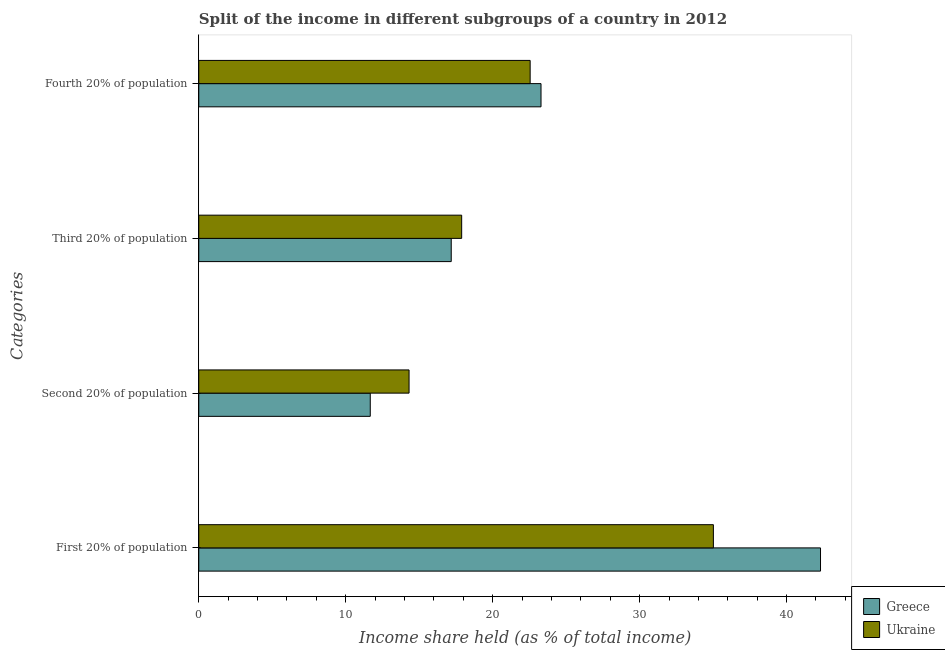How many bars are there on the 3rd tick from the top?
Keep it short and to the point. 2. How many bars are there on the 2nd tick from the bottom?
Ensure brevity in your answer.  2. What is the label of the 1st group of bars from the top?
Your response must be concise. Fourth 20% of population. What is the share of the income held by fourth 20% of the population in Ukraine?
Keep it short and to the point. 22.55. Across all countries, what is the maximum share of the income held by first 20% of the population?
Keep it short and to the point. 42.31. Across all countries, what is the minimum share of the income held by fourth 20% of the population?
Make the answer very short. 22.55. In which country was the share of the income held by second 20% of the population maximum?
Provide a short and direct response. Ukraine. What is the total share of the income held by first 20% of the population in the graph?
Offer a terse response. 77.33. What is the difference between the share of the income held by fourth 20% of the population in Greece and that in Ukraine?
Your answer should be compact. 0.74. What is the difference between the share of the income held by third 20% of the population in Greece and the share of the income held by first 20% of the population in Ukraine?
Provide a short and direct response. -17.84. What is the average share of the income held by fourth 20% of the population per country?
Your answer should be compact. 22.92. What is the difference between the share of the income held by first 20% of the population and share of the income held by second 20% of the population in Greece?
Provide a succinct answer. 30.64. In how many countries, is the share of the income held by third 20% of the population greater than 22 %?
Your response must be concise. 0. What is the ratio of the share of the income held by second 20% of the population in Greece to that in Ukraine?
Ensure brevity in your answer.  0.82. Is the difference between the share of the income held by second 20% of the population in Ukraine and Greece greater than the difference between the share of the income held by fourth 20% of the population in Ukraine and Greece?
Provide a succinct answer. Yes. What is the difference between the highest and the second highest share of the income held by second 20% of the population?
Make the answer very short. 2.64. What is the difference between the highest and the lowest share of the income held by second 20% of the population?
Your answer should be compact. 2.64. In how many countries, is the share of the income held by first 20% of the population greater than the average share of the income held by first 20% of the population taken over all countries?
Make the answer very short. 1. What does the 2nd bar from the top in Second 20% of population represents?
Offer a terse response. Greece. What does the 2nd bar from the bottom in Second 20% of population represents?
Provide a succinct answer. Ukraine. Are all the bars in the graph horizontal?
Provide a short and direct response. Yes. Where does the legend appear in the graph?
Your answer should be compact. Bottom right. How are the legend labels stacked?
Offer a terse response. Vertical. What is the title of the graph?
Provide a short and direct response. Split of the income in different subgroups of a country in 2012. What is the label or title of the X-axis?
Provide a short and direct response. Income share held (as % of total income). What is the label or title of the Y-axis?
Ensure brevity in your answer.  Categories. What is the Income share held (as % of total income) in Greece in First 20% of population?
Your response must be concise. 42.31. What is the Income share held (as % of total income) of Ukraine in First 20% of population?
Your answer should be very brief. 35.02. What is the Income share held (as % of total income) of Greece in Second 20% of population?
Give a very brief answer. 11.67. What is the Income share held (as % of total income) of Ukraine in Second 20% of population?
Offer a terse response. 14.31. What is the Income share held (as % of total income) in Greece in Third 20% of population?
Your response must be concise. 17.18. What is the Income share held (as % of total income) in Ukraine in Third 20% of population?
Provide a short and direct response. 17.89. What is the Income share held (as % of total income) of Greece in Fourth 20% of population?
Keep it short and to the point. 23.29. What is the Income share held (as % of total income) in Ukraine in Fourth 20% of population?
Your answer should be compact. 22.55. Across all Categories, what is the maximum Income share held (as % of total income) of Greece?
Give a very brief answer. 42.31. Across all Categories, what is the maximum Income share held (as % of total income) of Ukraine?
Your response must be concise. 35.02. Across all Categories, what is the minimum Income share held (as % of total income) in Greece?
Offer a terse response. 11.67. Across all Categories, what is the minimum Income share held (as % of total income) in Ukraine?
Give a very brief answer. 14.31. What is the total Income share held (as % of total income) in Greece in the graph?
Ensure brevity in your answer.  94.45. What is the total Income share held (as % of total income) in Ukraine in the graph?
Give a very brief answer. 89.77. What is the difference between the Income share held (as % of total income) in Greece in First 20% of population and that in Second 20% of population?
Give a very brief answer. 30.64. What is the difference between the Income share held (as % of total income) of Ukraine in First 20% of population and that in Second 20% of population?
Your answer should be very brief. 20.71. What is the difference between the Income share held (as % of total income) of Greece in First 20% of population and that in Third 20% of population?
Give a very brief answer. 25.13. What is the difference between the Income share held (as % of total income) in Ukraine in First 20% of population and that in Third 20% of population?
Keep it short and to the point. 17.13. What is the difference between the Income share held (as % of total income) in Greece in First 20% of population and that in Fourth 20% of population?
Make the answer very short. 19.02. What is the difference between the Income share held (as % of total income) of Ukraine in First 20% of population and that in Fourth 20% of population?
Keep it short and to the point. 12.47. What is the difference between the Income share held (as % of total income) in Greece in Second 20% of population and that in Third 20% of population?
Ensure brevity in your answer.  -5.51. What is the difference between the Income share held (as % of total income) of Ukraine in Second 20% of population and that in Third 20% of population?
Your answer should be very brief. -3.58. What is the difference between the Income share held (as % of total income) of Greece in Second 20% of population and that in Fourth 20% of population?
Make the answer very short. -11.62. What is the difference between the Income share held (as % of total income) of Ukraine in Second 20% of population and that in Fourth 20% of population?
Make the answer very short. -8.24. What is the difference between the Income share held (as % of total income) of Greece in Third 20% of population and that in Fourth 20% of population?
Provide a short and direct response. -6.11. What is the difference between the Income share held (as % of total income) in Ukraine in Third 20% of population and that in Fourth 20% of population?
Your answer should be very brief. -4.66. What is the difference between the Income share held (as % of total income) of Greece in First 20% of population and the Income share held (as % of total income) of Ukraine in Third 20% of population?
Make the answer very short. 24.42. What is the difference between the Income share held (as % of total income) in Greece in First 20% of population and the Income share held (as % of total income) in Ukraine in Fourth 20% of population?
Keep it short and to the point. 19.76. What is the difference between the Income share held (as % of total income) of Greece in Second 20% of population and the Income share held (as % of total income) of Ukraine in Third 20% of population?
Your answer should be very brief. -6.22. What is the difference between the Income share held (as % of total income) in Greece in Second 20% of population and the Income share held (as % of total income) in Ukraine in Fourth 20% of population?
Offer a very short reply. -10.88. What is the difference between the Income share held (as % of total income) in Greece in Third 20% of population and the Income share held (as % of total income) in Ukraine in Fourth 20% of population?
Ensure brevity in your answer.  -5.37. What is the average Income share held (as % of total income) of Greece per Categories?
Keep it short and to the point. 23.61. What is the average Income share held (as % of total income) in Ukraine per Categories?
Give a very brief answer. 22.44. What is the difference between the Income share held (as % of total income) in Greece and Income share held (as % of total income) in Ukraine in First 20% of population?
Your answer should be very brief. 7.29. What is the difference between the Income share held (as % of total income) in Greece and Income share held (as % of total income) in Ukraine in Second 20% of population?
Keep it short and to the point. -2.64. What is the difference between the Income share held (as % of total income) of Greece and Income share held (as % of total income) of Ukraine in Third 20% of population?
Provide a succinct answer. -0.71. What is the difference between the Income share held (as % of total income) of Greece and Income share held (as % of total income) of Ukraine in Fourth 20% of population?
Provide a succinct answer. 0.74. What is the ratio of the Income share held (as % of total income) in Greece in First 20% of population to that in Second 20% of population?
Keep it short and to the point. 3.63. What is the ratio of the Income share held (as % of total income) in Ukraine in First 20% of population to that in Second 20% of population?
Ensure brevity in your answer.  2.45. What is the ratio of the Income share held (as % of total income) of Greece in First 20% of population to that in Third 20% of population?
Your answer should be very brief. 2.46. What is the ratio of the Income share held (as % of total income) of Ukraine in First 20% of population to that in Third 20% of population?
Your response must be concise. 1.96. What is the ratio of the Income share held (as % of total income) of Greece in First 20% of population to that in Fourth 20% of population?
Your response must be concise. 1.82. What is the ratio of the Income share held (as % of total income) in Ukraine in First 20% of population to that in Fourth 20% of population?
Make the answer very short. 1.55. What is the ratio of the Income share held (as % of total income) of Greece in Second 20% of population to that in Third 20% of population?
Provide a short and direct response. 0.68. What is the ratio of the Income share held (as % of total income) of Ukraine in Second 20% of population to that in Third 20% of population?
Offer a terse response. 0.8. What is the ratio of the Income share held (as % of total income) in Greece in Second 20% of population to that in Fourth 20% of population?
Keep it short and to the point. 0.5. What is the ratio of the Income share held (as % of total income) of Ukraine in Second 20% of population to that in Fourth 20% of population?
Keep it short and to the point. 0.63. What is the ratio of the Income share held (as % of total income) of Greece in Third 20% of population to that in Fourth 20% of population?
Offer a terse response. 0.74. What is the ratio of the Income share held (as % of total income) of Ukraine in Third 20% of population to that in Fourth 20% of population?
Offer a terse response. 0.79. What is the difference between the highest and the second highest Income share held (as % of total income) in Greece?
Provide a succinct answer. 19.02. What is the difference between the highest and the second highest Income share held (as % of total income) of Ukraine?
Offer a very short reply. 12.47. What is the difference between the highest and the lowest Income share held (as % of total income) of Greece?
Keep it short and to the point. 30.64. What is the difference between the highest and the lowest Income share held (as % of total income) of Ukraine?
Your response must be concise. 20.71. 